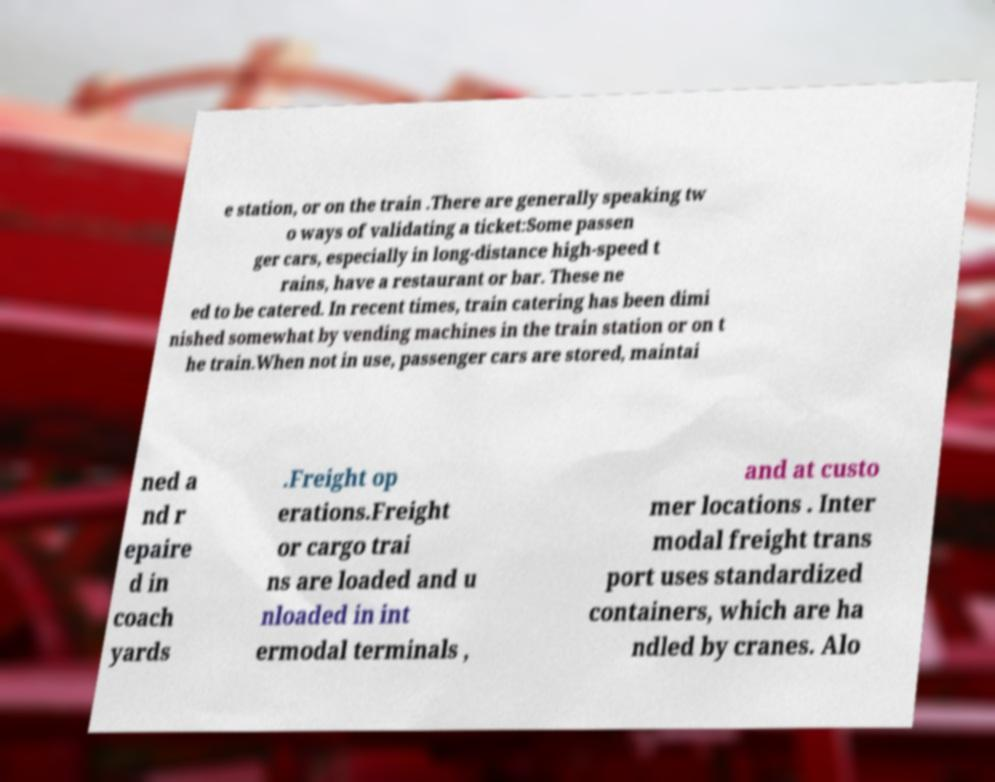Please read and relay the text visible in this image. What does it say? e station, or on the train .There are generally speaking tw o ways of validating a ticket:Some passen ger cars, especially in long-distance high-speed t rains, have a restaurant or bar. These ne ed to be catered. In recent times, train catering has been dimi nished somewhat by vending machines in the train station or on t he train.When not in use, passenger cars are stored, maintai ned a nd r epaire d in coach yards .Freight op erations.Freight or cargo trai ns are loaded and u nloaded in int ermodal terminals , and at custo mer locations . Inter modal freight trans port uses standardized containers, which are ha ndled by cranes. Alo 